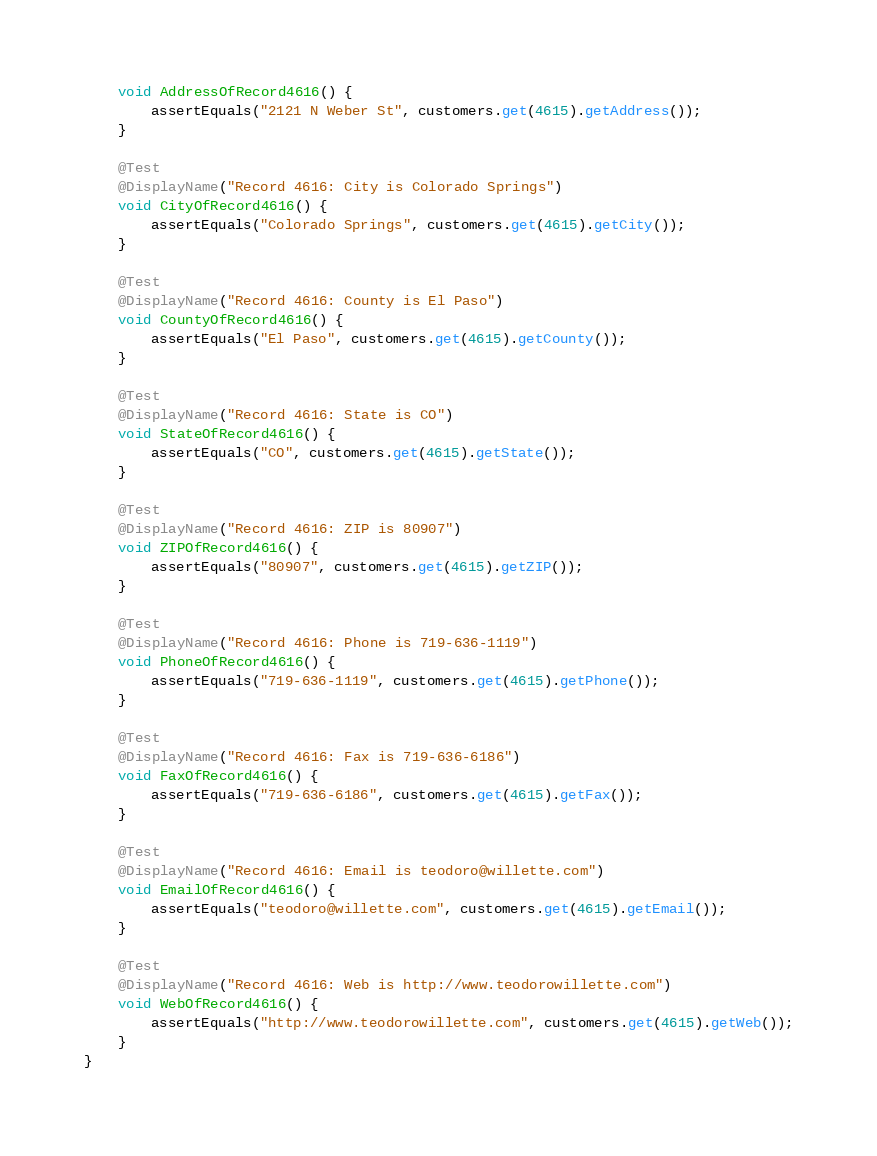<code> <loc_0><loc_0><loc_500><loc_500><_Java_>	void AddressOfRecord4616() {
		assertEquals("2121 N Weber St", customers.get(4615).getAddress());
	}

	@Test
	@DisplayName("Record 4616: City is Colorado Springs")
	void CityOfRecord4616() {
		assertEquals("Colorado Springs", customers.get(4615).getCity());
	}

	@Test
	@DisplayName("Record 4616: County is El Paso")
	void CountyOfRecord4616() {
		assertEquals("El Paso", customers.get(4615).getCounty());
	}

	@Test
	@DisplayName("Record 4616: State is CO")
	void StateOfRecord4616() {
		assertEquals("CO", customers.get(4615).getState());
	}

	@Test
	@DisplayName("Record 4616: ZIP is 80907")
	void ZIPOfRecord4616() {
		assertEquals("80907", customers.get(4615).getZIP());
	}

	@Test
	@DisplayName("Record 4616: Phone is 719-636-1119")
	void PhoneOfRecord4616() {
		assertEquals("719-636-1119", customers.get(4615).getPhone());
	}

	@Test
	@DisplayName("Record 4616: Fax is 719-636-6186")
	void FaxOfRecord4616() {
		assertEquals("719-636-6186", customers.get(4615).getFax());
	}

	@Test
	@DisplayName("Record 4616: Email is teodoro@willette.com")
	void EmailOfRecord4616() {
		assertEquals("teodoro@willette.com", customers.get(4615).getEmail());
	}

	@Test
	@DisplayName("Record 4616: Web is http://www.teodorowillette.com")
	void WebOfRecord4616() {
		assertEquals("http://www.teodorowillette.com", customers.get(4615).getWeb());
	}
}
</code> 